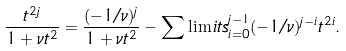Convert formula to latex. <formula><loc_0><loc_0><loc_500><loc_500>\frac { t ^ { 2 j } } { 1 + \nu { t ^ { 2 } } } = \frac { ( - 1 / \nu ) ^ { j } } { 1 + \nu { t ^ { 2 } } } - \sum \lim i t s _ { i = 0 } ^ { j - 1 } ( - 1 / \nu ) ^ { j - i } t ^ { 2 i } .</formula> 